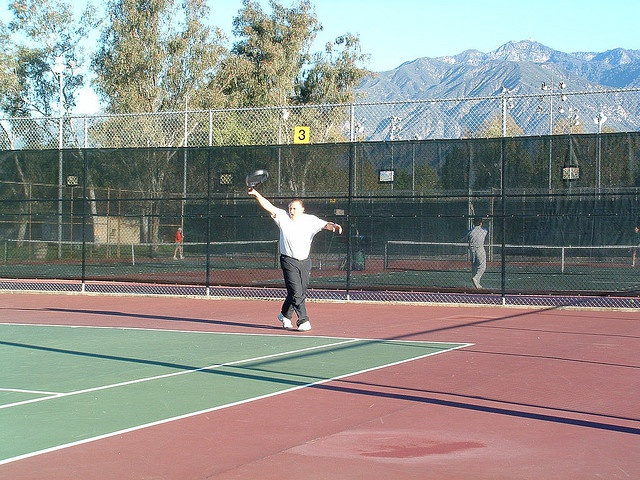Describe the objects in this image and their specific colors. I can see people in lightblue, white, gray, black, and darkgray tones, people in lightblue, darkgray, gray, purple, and black tones, tennis racket in lightblue, gray, black, darkgray, and purple tones, people in lightblue, gray, darkgray, brown, and salmon tones, and people in lightblue, purple, gray, black, and darkgray tones in this image. 